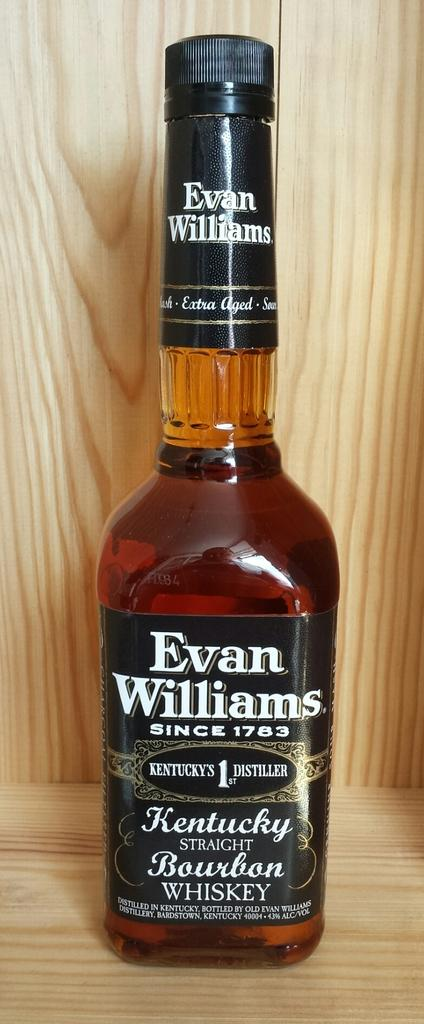<image>
Render a clear and concise summary of the photo. An unopen bottle of Evan Williams Kentucky Bourbon is alone on a shelf. 